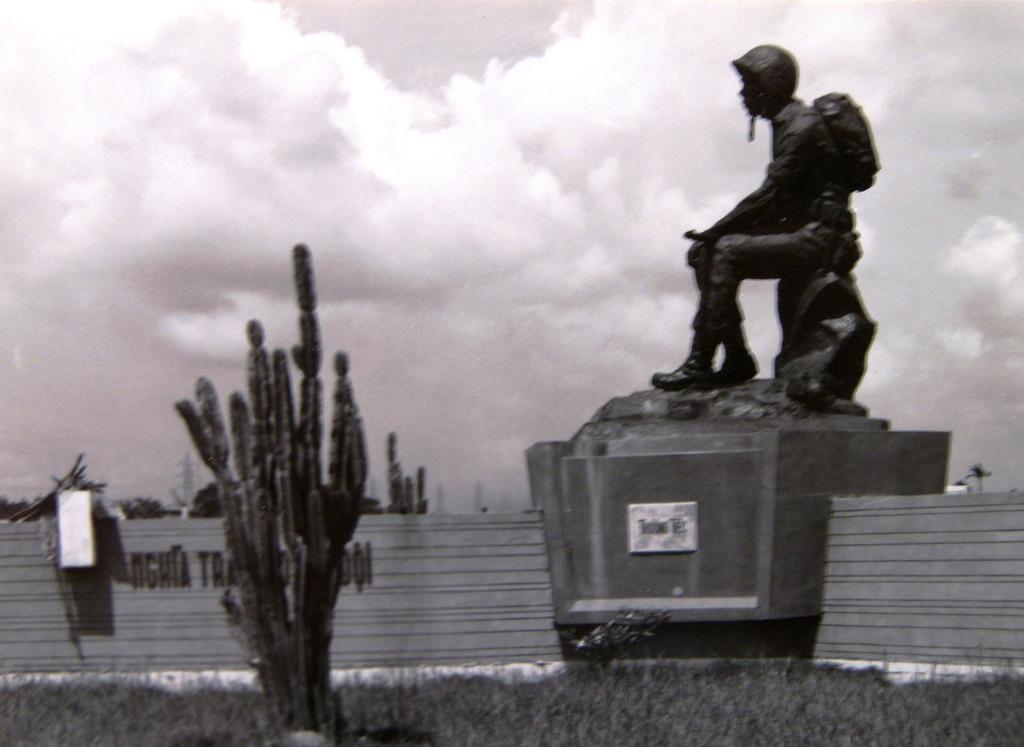Can you describe this image briefly? Here we can see sculpture and we can see plant,grass and wall. Background we can see sky with clouds. 